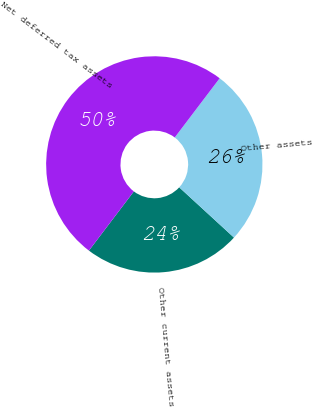<chart> <loc_0><loc_0><loc_500><loc_500><pie_chart><fcel>Other current assets<fcel>Other assets<fcel>Net deferred tax assets<nl><fcel>23.51%<fcel>26.49%<fcel>50.0%<nl></chart> 